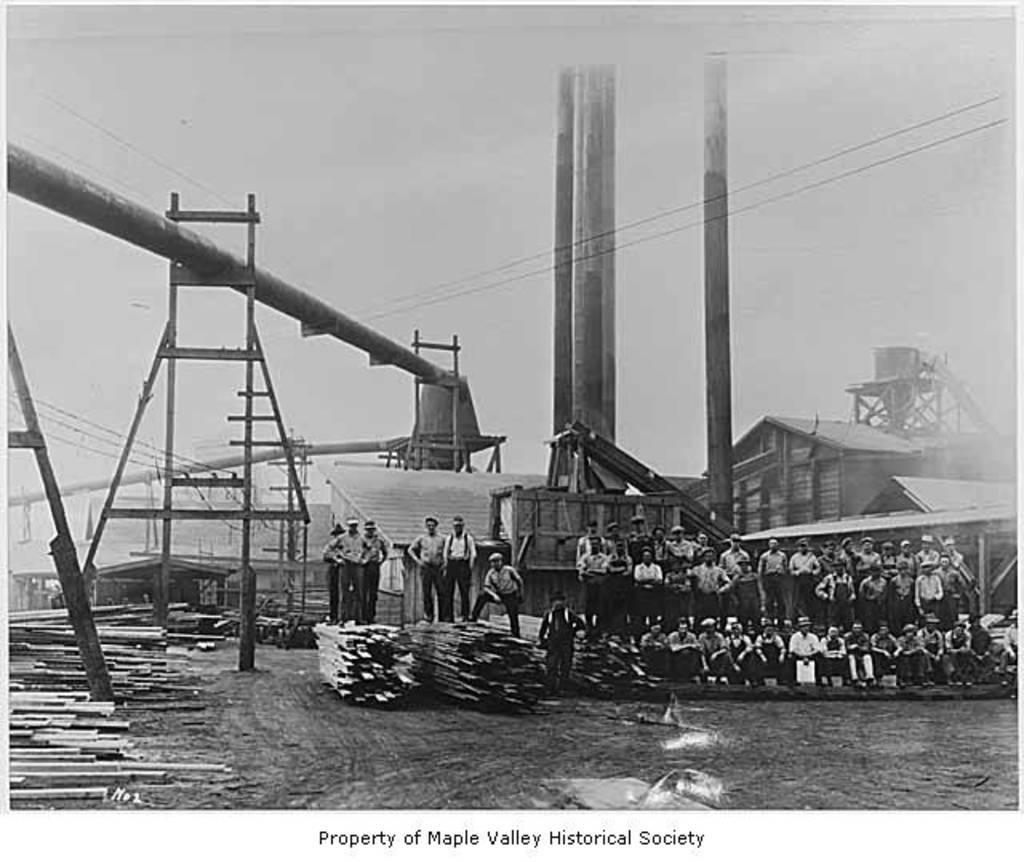How would you summarize this image in a sentence or two? It is a black and white picture. In the center of the image we can see the sky, houses, pillars, few people are standing, few people are sitting and a few other objects. At the bottom of the image, we can see some text. 